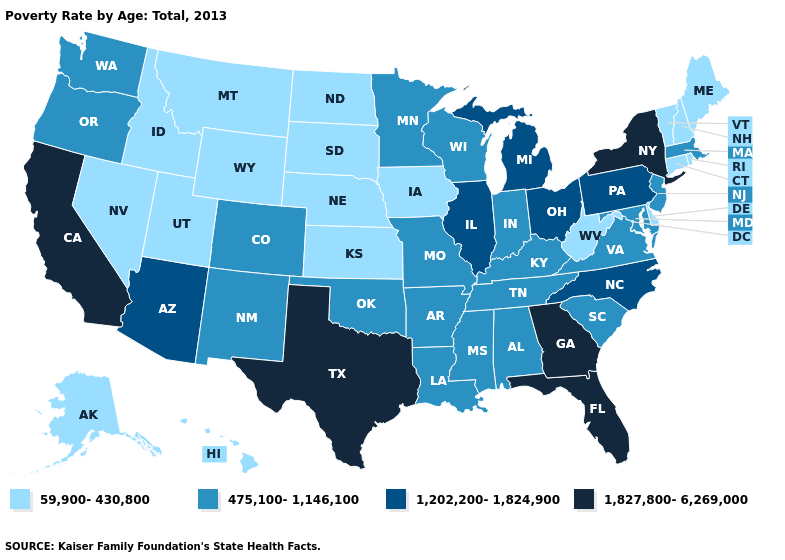Does the first symbol in the legend represent the smallest category?
Quick response, please. Yes. What is the value of Florida?
Concise answer only. 1,827,800-6,269,000. What is the highest value in the USA?
Short answer required. 1,827,800-6,269,000. What is the lowest value in the West?
Concise answer only. 59,900-430,800. How many symbols are there in the legend?
Keep it brief. 4. What is the highest value in the West ?
Concise answer only. 1,827,800-6,269,000. Does Georgia have a lower value than Florida?
Write a very short answer. No. What is the value of Wyoming?
Short answer required. 59,900-430,800. Is the legend a continuous bar?
Give a very brief answer. No. Does Delaware have the highest value in the South?
Short answer required. No. What is the lowest value in the South?
Answer briefly. 59,900-430,800. What is the lowest value in states that border North Dakota?
Be succinct. 59,900-430,800. Is the legend a continuous bar?
Write a very short answer. No. What is the lowest value in the Northeast?
Answer briefly. 59,900-430,800. Among the states that border Colorado , which have the lowest value?
Give a very brief answer. Kansas, Nebraska, Utah, Wyoming. 